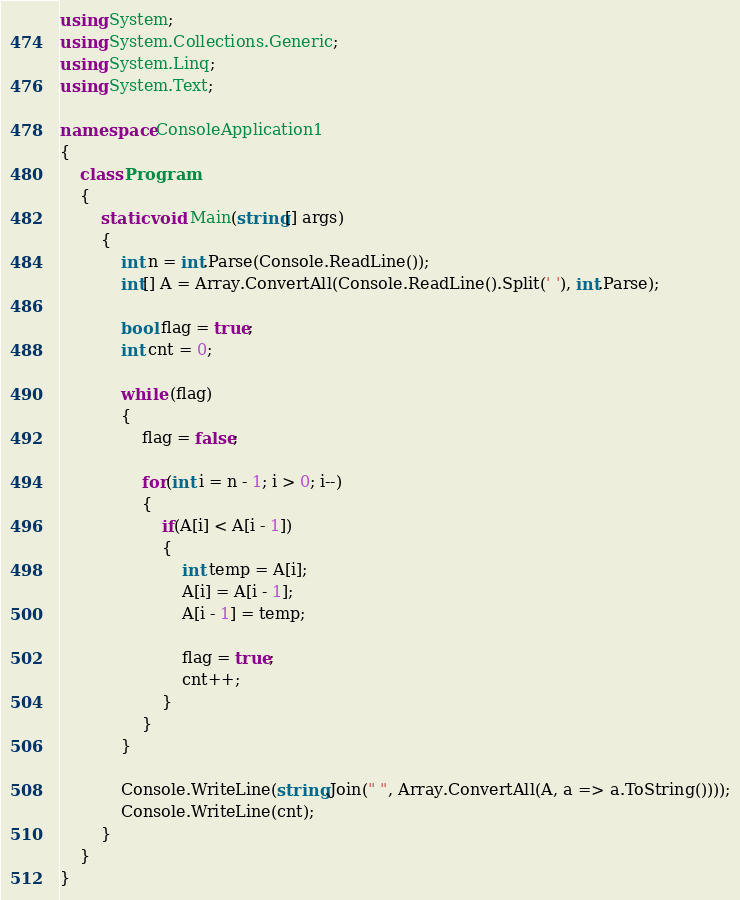Convert code to text. <code><loc_0><loc_0><loc_500><loc_500><_C#_>using System;
using System.Collections.Generic;
using System.Linq;
using System.Text;

namespace ConsoleApplication1
{
    class Program
    {
        static void Main(string[] args)
        {
            int n = int.Parse(Console.ReadLine());
            int[] A = Array.ConvertAll(Console.ReadLine().Split(' '), int.Parse);

            bool flag = true;
            int cnt = 0;

            while (flag)
            {
                flag = false;

                for(int i = n - 1; i > 0; i--)
                {
                    if(A[i] < A[i - 1])
                    {
                        int temp = A[i];
                        A[i] = A[i - 1];
                        A[i - 1] = temp;

                        flag = true;
                        cnt++;
                    }
                }
            }

            Console.WriteLine(string.Join(" ", Array.ConvertAll(A, a => a.ToString())));
            Console.WriteLine(cnt);
        }
    }
}</code> 